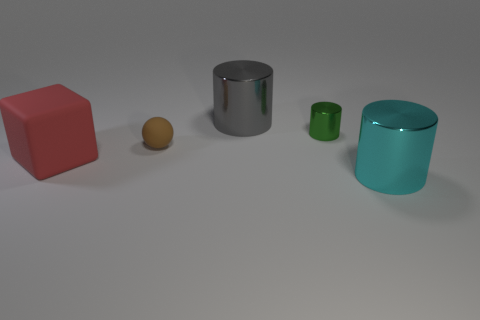Subtract all big metallic cylinders. How many cylinders are left? 1 Add 5 shiny cylinders. How many objects exist? 10 Subtract all blocks. How many objects are left? 4 Subtract all large gray objects. Subtract all gray things. How many objects are left? 3 Add 2 small cylinders. How many small cylinders are left? 3 Add 2 yellow spheres. How many yellow spheres exist? 2 Subtract 1 red cubes. How many objects are left? 4 